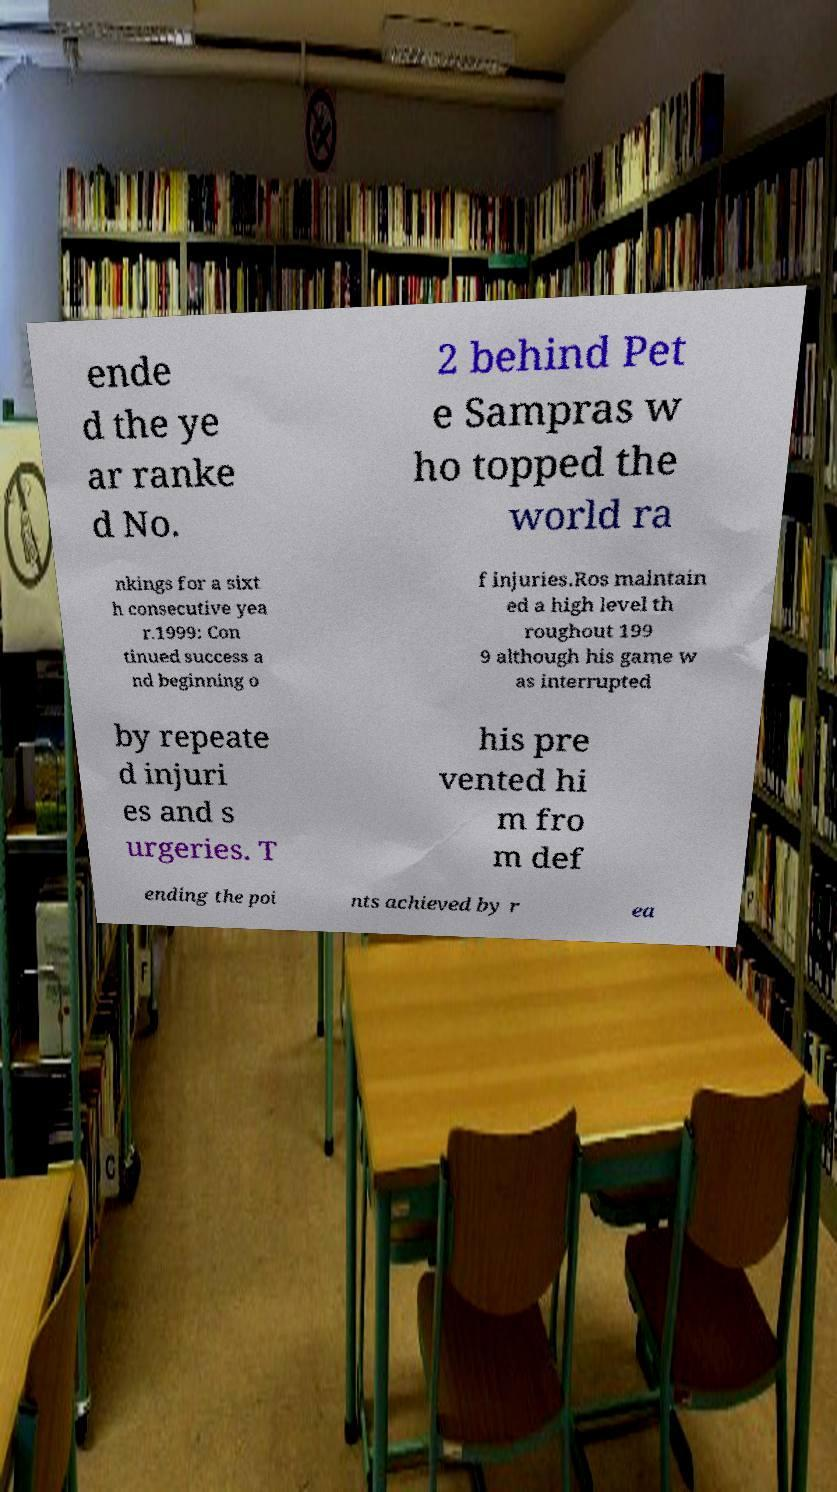For documentation purposes, I need the text within this image transcribed. Could you provide that? ende d the ye ar ranke d No. 2 behind Pet e Sampras w ho topped the world ra nkings for a sixt h consecutive yea r.1999: Con tinued success a nd beginning o f injuries.Ros maintain ed a high level th roughout 199 9 although his game w as interrupted by repeate d injuri es and s urgeries. T his pre vented hi m fro m def ending the poi nts achieved by r ea 